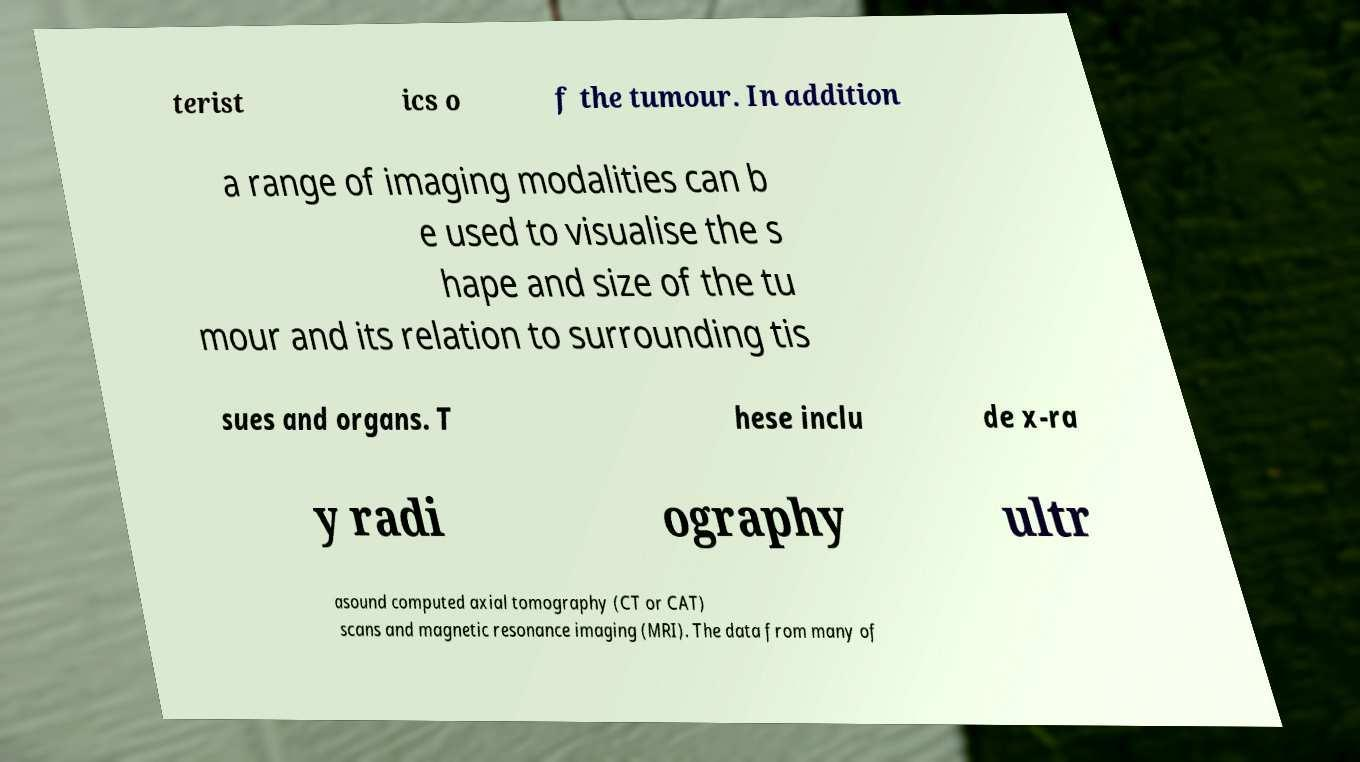Please read and relay the text visible in this image. What does it say? terist ics o f the tumour. In addition a range of imaging modalities can b e used to visualise the s hape and size of the tu mour and its relation to surrounding tis sues and organs. T hese inclu de x-ra y radi ography ultr asound computed axial tomography (CT or CAT) scans and magnetic resonance imaging (MRI). The data from many of 